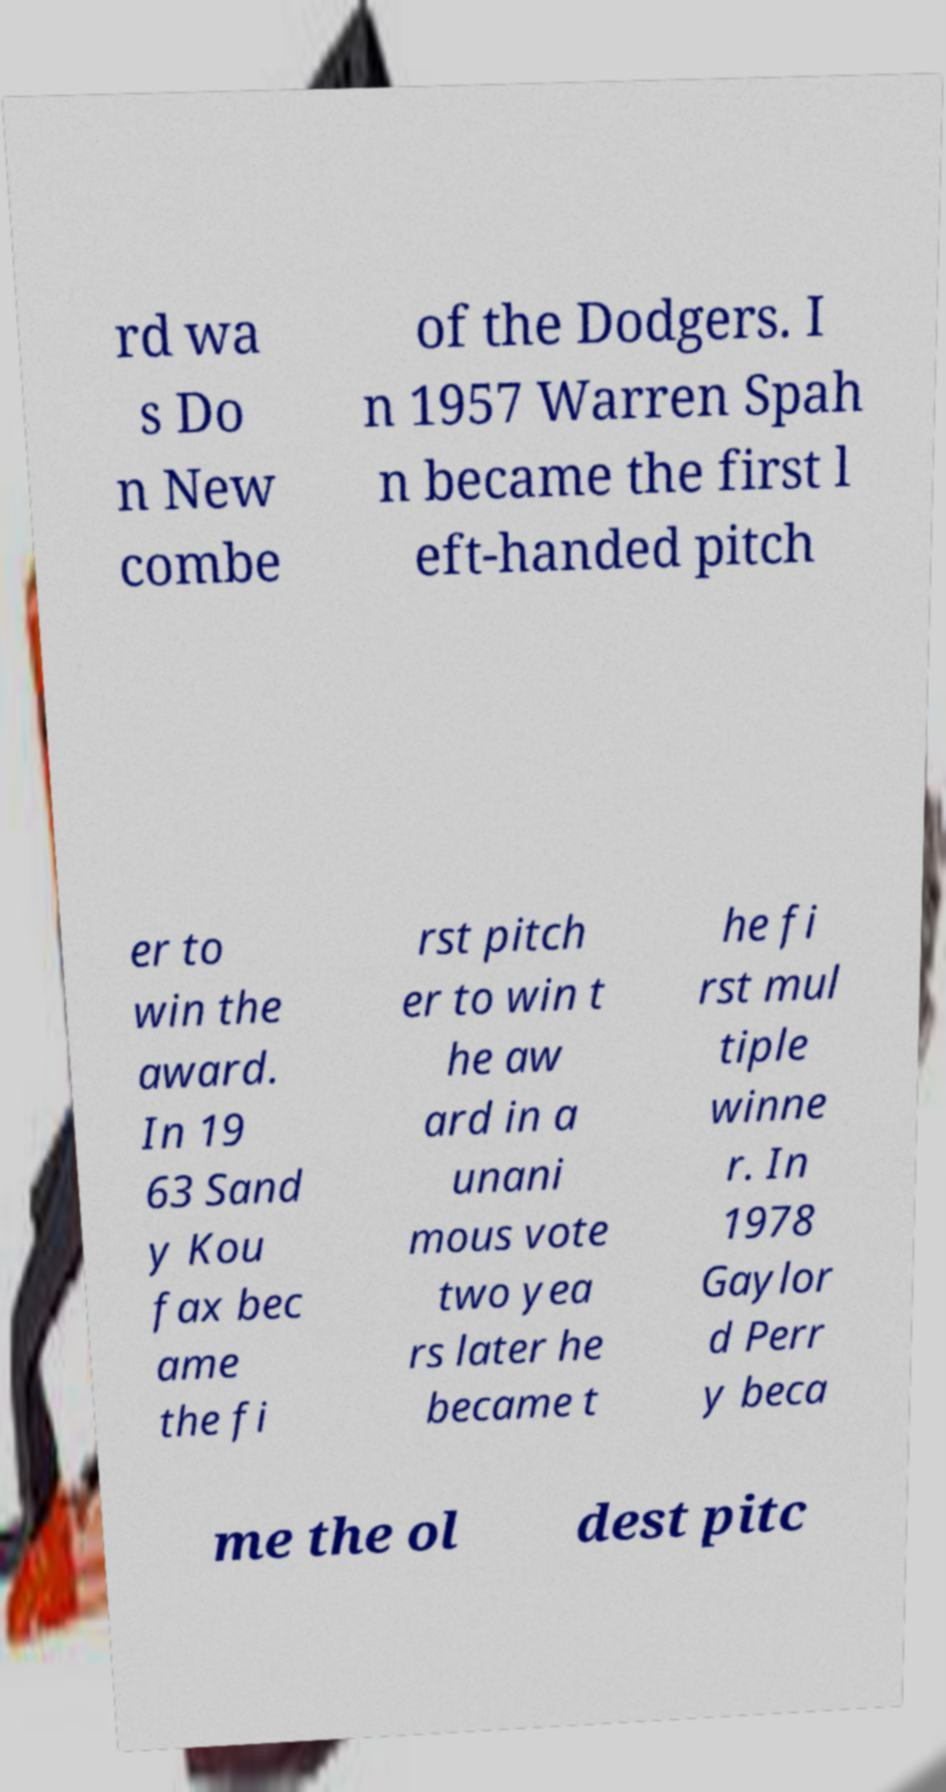What messages or text are displayed in this image? I need them in a readable, typed format. rd wa s Do n New combe of the Dodgers. I n 1957 Warren Spah n became the first l eft-handed pitch er to win the award. In 19 63 Sand y Kou fax bec ame the fi rst pitch er to win t he aw ard in a unani mous vote two yea rs later he became t he fi rst mul tiple winne r. In 1978 Gaylor d Perr y beca me the ol dest pitc 